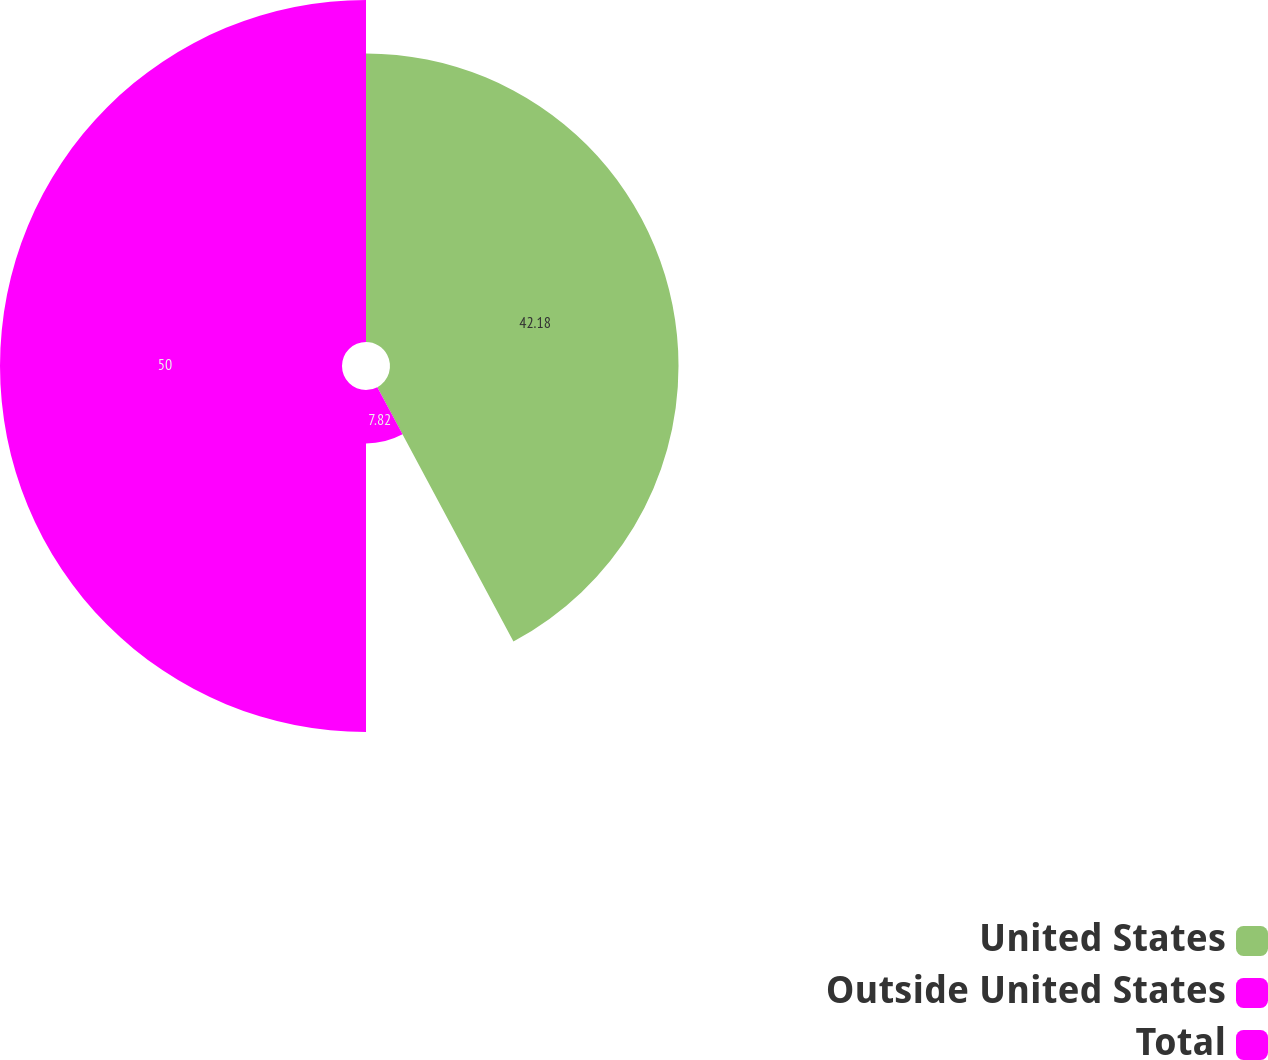<chart> <loc_0><loc_0><loc_500><loc_500><pie_chart><fcel>United States<fcel>Outside United States<fcel>Total<nl><fcel>42.18%<fcel>7.82%<fcel>50.0%<nl></chart> 